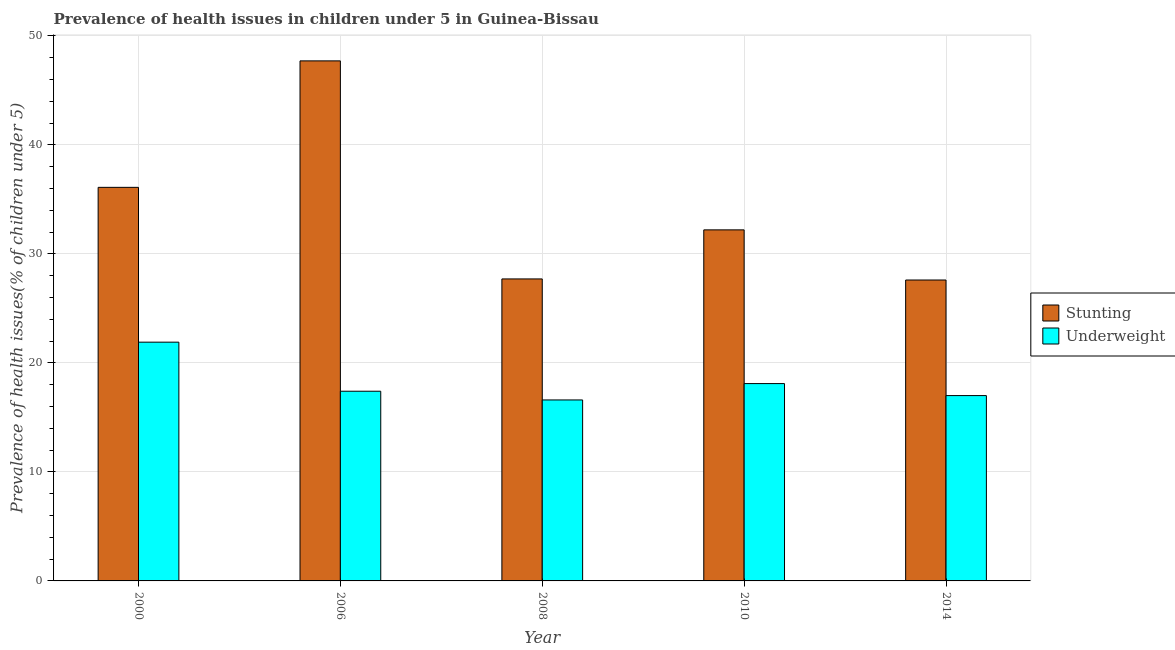How many different coloured bars are there?
Offer a terse response. 2. Are the number of bars per tick equal to the number of legend labels?
Provide a succinct answer. Yes. How many bars are there on the 4th tick from the left?
Offer a terse response. 2. How many bars are there on the 3rd tick from the right?
Provide a succinct answer. 2. What is the label of the 3rd group of bars from the left?
Provide a succinct answer. 2008. What is the percentage of stunted children in 2014?
Ensure brevity in your answer.  27.6. Across all years, what is the maximum percentage of stunted children?
Your answer should be very brief. 47.7. Across all years, what is the minimum percentage of underweight children?
Your response must be concise. 16.6. In which year was the percentage of stunted children minimum?
Your answer should be very brief. 2014. What is the total percentage of underweight children in the graph?
Your answer should be very brief. 91. What is the difference between the percentage of underweight children in 2006 and that in 2010?
Offer a very short reply. -0.7. What is the difference between the percentage of stunted children in 2010 and the percentage of underweight children in 2006?
Make the answer very short. -15.5. What is the average percentage of stunted children per year?
Provide a succinct answer. 34.26. In how many years, is the percentage of stunted children greater than 24 %?
Your answer should be very brief. 5. What is the ratio of the percentage of underweight children in 2000 to that in 2010?
Your answer should be compact. 1.21. What is the difference between the highest and the second highest percentage of underweight children?
Provide a short and direct response. 3.8. What is the difference between the highest and the lowest percentage of underweight children?
Give a very brief answer. 5.3. In how many years, is the percentage of stunted children greater than the average percentage of stunted children taken over all years?
Offer a terse response. 2. Is the sum of the percentage of underweight children in 2000 and 2010 greater than the maximum percentage of stunted children across all years?
Provide a succinct answer. Yes. What does the 2nd bar from the left in 2008 represents?
Give a very brief answer. Underweight. What does the 1st bar from the right in 2010 represents?
Your response must be concise. Underweight. Are all the bars in the graph horizontal?
Provide a short and direct response. No. How many years are there in the graph?
Your response must be concise. 5. Are the values on the major ticks of Y-axis written in scientific E-notation?
Offer a terse response. No. Does the graph contain grids?
Offer a very short reply. Yes. Where does the legend appear in the graph?
Your answer should be very brief. Center right. How are the legend labels stacked?
Ensure brevity in your answer.  Vertical. What is the title of the graph?
Provide a short and direct response. Prevalence of health issues in children under 5 in Guinea-Bissau. What is the label or title of the Y-axis?
Provide a succinct answer. Prevalence of health issues(% of children under 5). What is the Prevalence of health issues(% of children under 5) of Stunting in 2000?
Offer a terse response. 36.1. What is the Prevalence of health issues(% of children under 5) of Underweight in 2000?
Offer a terse response. 21.9. What is the Prevalence of health issues(% of children under 5) of Stunting in 2006?
Give a very brief answer. 47.7. What is the Prevalence of health issues(% of children under 5) in Underweight in 2006?
Provide a short and direct response. 17.4. What is the Prevalence of health issues(% of children under 5) in Stunting in 2008?
Your answer should be very brief. 27.7. What is the Prevalence of health issues(% of children under 5) in Underweight in 2008?
Provide a short and direct response. 16.6. What is the Prevalence of health issues(% of children under 5) of Stunting in 2010?
Offer a very short reply. 32.2. What is the Prevalence of health issues(% of children under 5) of Underweight in 2010?
Your answer should be very brief. 18.1. What is the Prevalence of health issues(% of children under 5) in Stunting in 2014?
Ensure brevity in your answer.  27.6. Across all years, what is the maximum Prevalence of health issues(% of children under 5) of Stunting?
Give a very brief answer. 47.7. Across all years, what is the maximum Prevalence of health issues(% of children under 5) of Underweight?
Offer a terse response. 21.9. Across all years, what is the minimum Prevalence of health issues(% of children under 5) in Stunting?
Make the answer very short. 27.6. Across all years, what is the minimum Prevalence of health issues(% of children under 5) in Underweight?
Make the answer very short. 16.6. What is the total Prevalence of health issues(% of children under 5) in Stunting in the graph?
Ensure brevity in your answer.  171.3. What is the total Prevalence of health issues(% of children under 5) in Underweight in the graph?
Provide a short and direct response. 91. What is the difference between the Prevalence of health issues(% of children under 5) in Stunting in 2000 and that in 2006?
Your response must be concise. -11.6. What is the difference between the Prevalence of health issues(% of children under 5) of Underweight in 2000 and that in 2006?
Offer a very short reply. 4.5. What is the difference between the Prevalence of health issues(% of children under 5) in Stunting in 2000 and that in 2008?
Provide a short and direct response. 8.4. What is the difference between the Prevalence of health issues(% of children under 5) in Underweight in 2000 and that in 2008?
Your answer should be very brief. 5.3. What is the difference between the Prevalence of health issues(% of children under 5) of Stunting in 2000 and that in 2010?
Your answer should be very brief. 3.9. What is the difference between the Prevalence of health issues(% of children under 5) in Stunting in 2006 and that in 2008?
Keep it short and to the point. 20. What is the difference between the Prevalence of health issues(% of children under 5) in Stunting in 2006 and that in 2014?
Your answer should be compact. 20.1. What is the difference between the Prevalence of health issues(% of children under 5) of Underweight in 2008 and that in 2010?
Make the answer very short. -1.5. What is the difference between the Prevalence of health issues(% of children under 5) of Stunting in 2008 and that in 2014?
Your answer should be compact. 0.1. What is the difference between the Prevalence of health issues(% of children under 5) in Underweight in 2008 and that in 2014?
Your answer should be very brief. -0.4. What is the difference between the Prevalence of health issues(% of children under 5) in Stunting in 2010 and that in 2014?
Ensure brevity in your answer.  4.6. What is the difference between the Prevalence of health issues(% of children under 5) of Stunting in 2000 and the Prevalence of health issues(% of children under 5) of Underweight in 2006?
Keep it short and to the point. 18.7. What is the difference between the Prevalence of health issues(% of children under 5) of Stunting in 2000 and the Prevalence of health issues(% of children under 5) of Underweight in 2008?
Provide a short and direct response. 19.5. What is the difference between the Prevalence of health issues(% of children under 5) in Stunting in 2000 and the Prevalence of health issues(% of children under 5) in Underweight in 2010?
Keep it short and to the point. 18. What is the difference between the Prevalence of health issues(% of children under 5) in Stunting in 2000 and the Prevalence of health issues(% of children under 5) in Underweight in 2014?
Ensure brevity in your answer.  19.1. What is the difference between the Prevalence of health issues(% of children under 5) of Stunting in 2006 and the Prevalence of health issues(% of children under 5) of Underweight in 2008?
Your response must be concise. 31.1. What is the difference between the Prevalence of health issues(% of children under 5) in Stunting in 2006 and the Prevalence of health issues(% of children under 5) in Underweight in 2010?
Your answer should be very brief. 29.6. What is the difference between the Prevalence of health issues(% of children under 5) in Stunting in 2006 and the Prevalence of health issues(% of children under 5) in Underweight in 2014?
Your answer should be compact. 30.7. What is the difference between the Prevalence of health issues(% of children under 5) in Stunting in 2008 and the Prevalence of health issues(% of children under 5) in Underweight in 2010?
Provide a succinct answer. 9.6. What is the difference between the Prevalence of health issues(% of children under 5) in Stunting in 2008 and the Prevalence of health issues(% of children under 5) in Underweight in 2014?
Offer a terse response. 10.7. What is the average Prevalence of health issues(% of children under 5) in Stunting per year?
Offer a very short reply. 34.26. In the year 2000, what is the difference between the Prevalence of health issues(% of children under 5) of Stunting and Prevalence of health issues(% of children under 5) of Underweight?
Your answer should be very brief. 14.2. In the year 2006, what is the difference between the Prevalence of health issues(% of children under 5) of Stunting and Prevalence of health issues(% of children under 5) of Underweight?
Your answer should be compact. 30.3. What is the ratio of the Prevalence of health issues(% of children under 5) in Stunting in 2000 to that in 2006?
Offer a very short reply. 0.76. What is the ratio of the Prevalence of health issues(% of children under 5) of Underweight in 2000 to that in 2006?
Provide a short and direct response. 1.26. What is the ratio of the Prevalence of health issues(% of children under 5) in Stunting in 2000 to that in 2008?
Offer a very short reply. 1.3. What is the ratio of the Prevalence of health issues(% of children under 5) of Underweight in 2000 to that in 2008?
Make the answer very short. 1.32. What is the ratio of the Prevalence of health issues(% of children under 5) in Stunting in 2000 to that in 2010?
Offer a terse response. 1.12. What is the ratio of the Prevalence of health issues(% of children under 5) of Underweight in 2000 to that in 2010?
Keep it short and to the point. 1.21. What is the ratio of the Prevalence of health issues(% of children under 5) of Stunting in 2000 to that in 2014?
Your response must be concise. 1.31. What is the ratio of the Prevalence of health issues(% of children under 5) of Underweight in 2000 to that in 2014?
Provide a short and direct response. 1.29. What is the ratio of the Prevalence of health issues(% of children under 5) in Stunting in 2006 to that in 2008?
Make the answer very short. 1.72. What is the ratio of the Prevalence of health issues(% of children under 5) in Underweight in 2006 to that in 2008?
Your answer should be very brief. 1.05. What is the ratio of the Prevalence of health issues(% of children under 5) of Stunting in 2006 to that in 2010?
Keep it short and to the point. 1.48. What is the ratio of the Prevalence of health issues(% of children under 5) of Underweight in 2006 to that in 2010?
Give a very brief answer. 0.96. What is the ratio of the Prevalence of health issues(% of children under 5) in Stunting in 2006 to that in 2014?
Give a very brief answer. 1.73. What is the ratio of the Prevalence of health issues(% of children under 5) in Underweight in 2006 to that in 2014?
Your answer should be compact. 1.02. What is the ratio of the Prevalence of health issues(% of children under 5) in Stunting in 2008 to that in 2010?
Your answer should be compact. 0.86. What is the ratio of the Prevalence of health issues(% of children under 5) in Underweight in 2008 to that in 2010?
Your response must be concise. 0.92. What is the ratio of the Prevalence of health issues(% of children under 5) in Stunting in 2008 to that in 2014?
Your answer should be compact. 1. What is the ratio of the Prevalence of health issues(% of children under 5) of Underweight in 2008 to that in 2014?
Offer a terse response. 0.98. What is the ratio of the Prevalence of health issues(% of children under 5) in Underweight in 2010 to that in 2014?
Your response must be concise. 1.06. What is the difference between the highest and the second highest Prevalence of health issues(% of children under 5) of Stunting?
Your answer should be very brief. 11.6. What is the difference between the highest and the lowest Prevalence of health issues(% of children under 5) of Stunting?
Make the answer very short. 20.1. What is the difference between the highest and the lowest Prevalence of health issues(% of children under 5) of Underweight?
Offer a terse response. 5.3. 